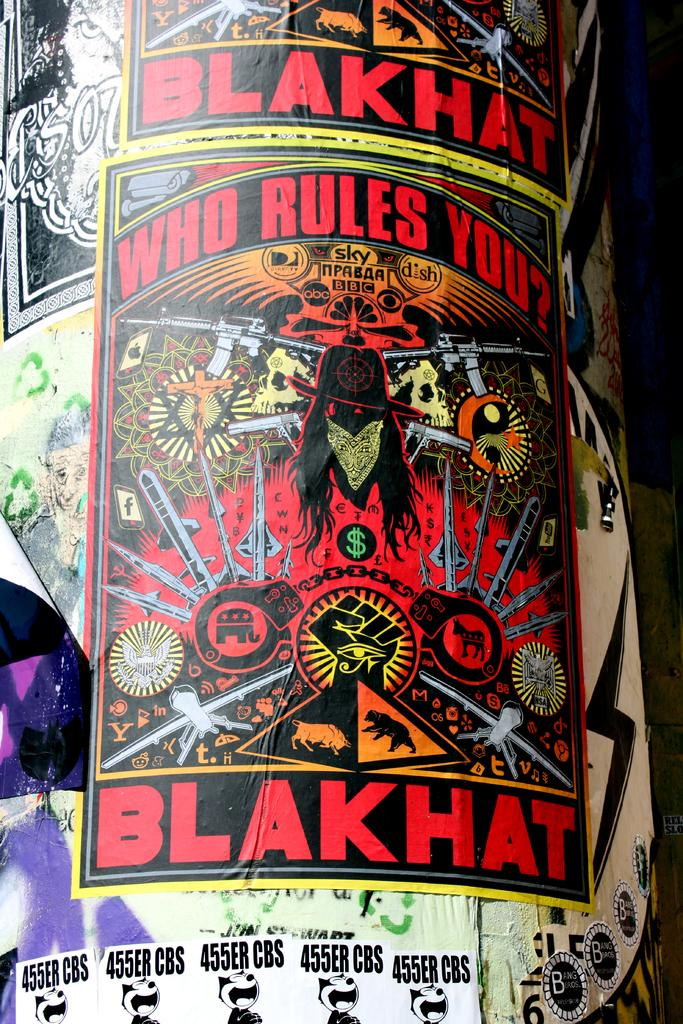What is on the pillar in the image? There are posters on a pillar in the image. What can be read on the posters? There is text visible on the posters. What type of berry is growing on the back of the pillar in the image? There are no berries present on the pillar or its back in the image. 